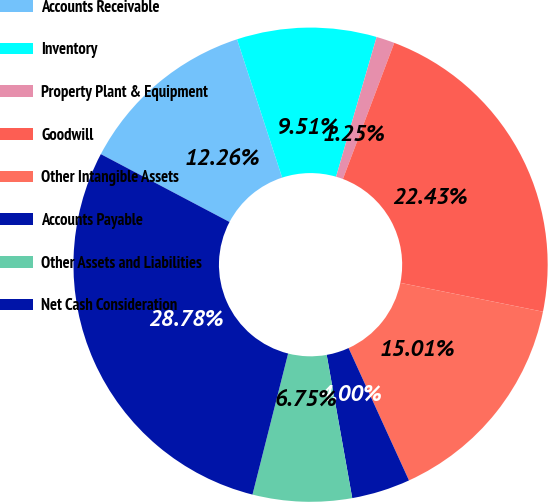<chart> <loc_0><loc_0><loc_500><loc_500><pie_chart><fcel>Accounts Receivable<fcel>Inventory<fcel>Property Plant & Equipment<fcel>Goodwill<fcel>Other Intangible Assets<fcel>Accounts Payable<fcel>Other Assets and Liabilities<fcel>Net Cash Consideration<nl><fcel>12.26%<fcel>9.51%<fcel>1.25%<fcel>22.43%<fcel>15.01%<fcel>4.0%<fcel>6.75%<fcel>28.78%<nl></chart> 